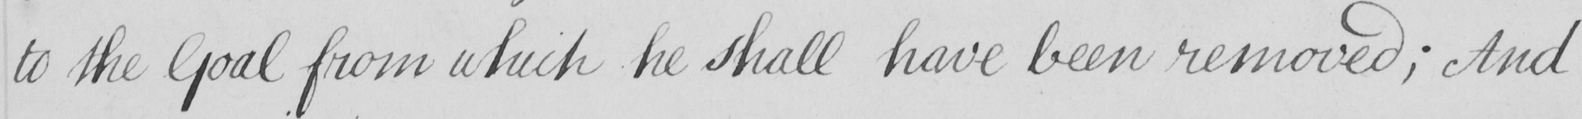Can you tell me what this handwritten text says? to the Goal from which he shall have been removed ; And 